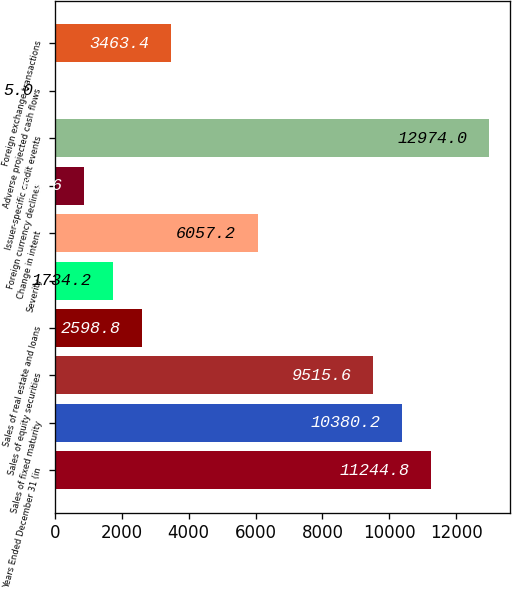Convert chart. <chart><loc_0><loc_0><loc_500><loc_500><bar_chart><fcel>Years Ended December 31 (in<fcel>Sales of fixed maturity<fcel>Sales of equity securities<fcel>Sales of real estate and loans<fcel>Severity<fcel>Change in intent<fcel>Foreign currency declines<fcel>Issuer-specific credit events<fcel>Adverse projected cash flows<fcel>Foreign exchange transactions<nl><fcel>11244.8<fcel>10380.2<fcel>9515.6<fcel>2598.8<fcel>1734.2<fcel>6057.2<fcel>869.6<fcel>12974<fcel>5<fcel>3463.4<nl></chart> 